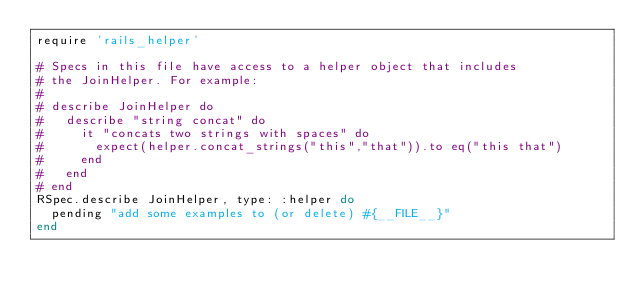Convert code to text. <code><loc_0><loc_0><loc_500><loc_500><_Ruby_>require 'rails_helper'

# Specs in this file have access to a helper object that includes
# the JoinHelper. For example:
#
# describe JoinHelper do
#   describe "string concat" do
#     it "concats two strings with spaces" do
#       expect(helper.concat_strings("this","that")).to eq("this that")
#     end
#   end
# end
RSpec.describe JoinHelper, type: :helper do
  pending "add some examples to (or delete) #{__FILE__}"
end
</code> 